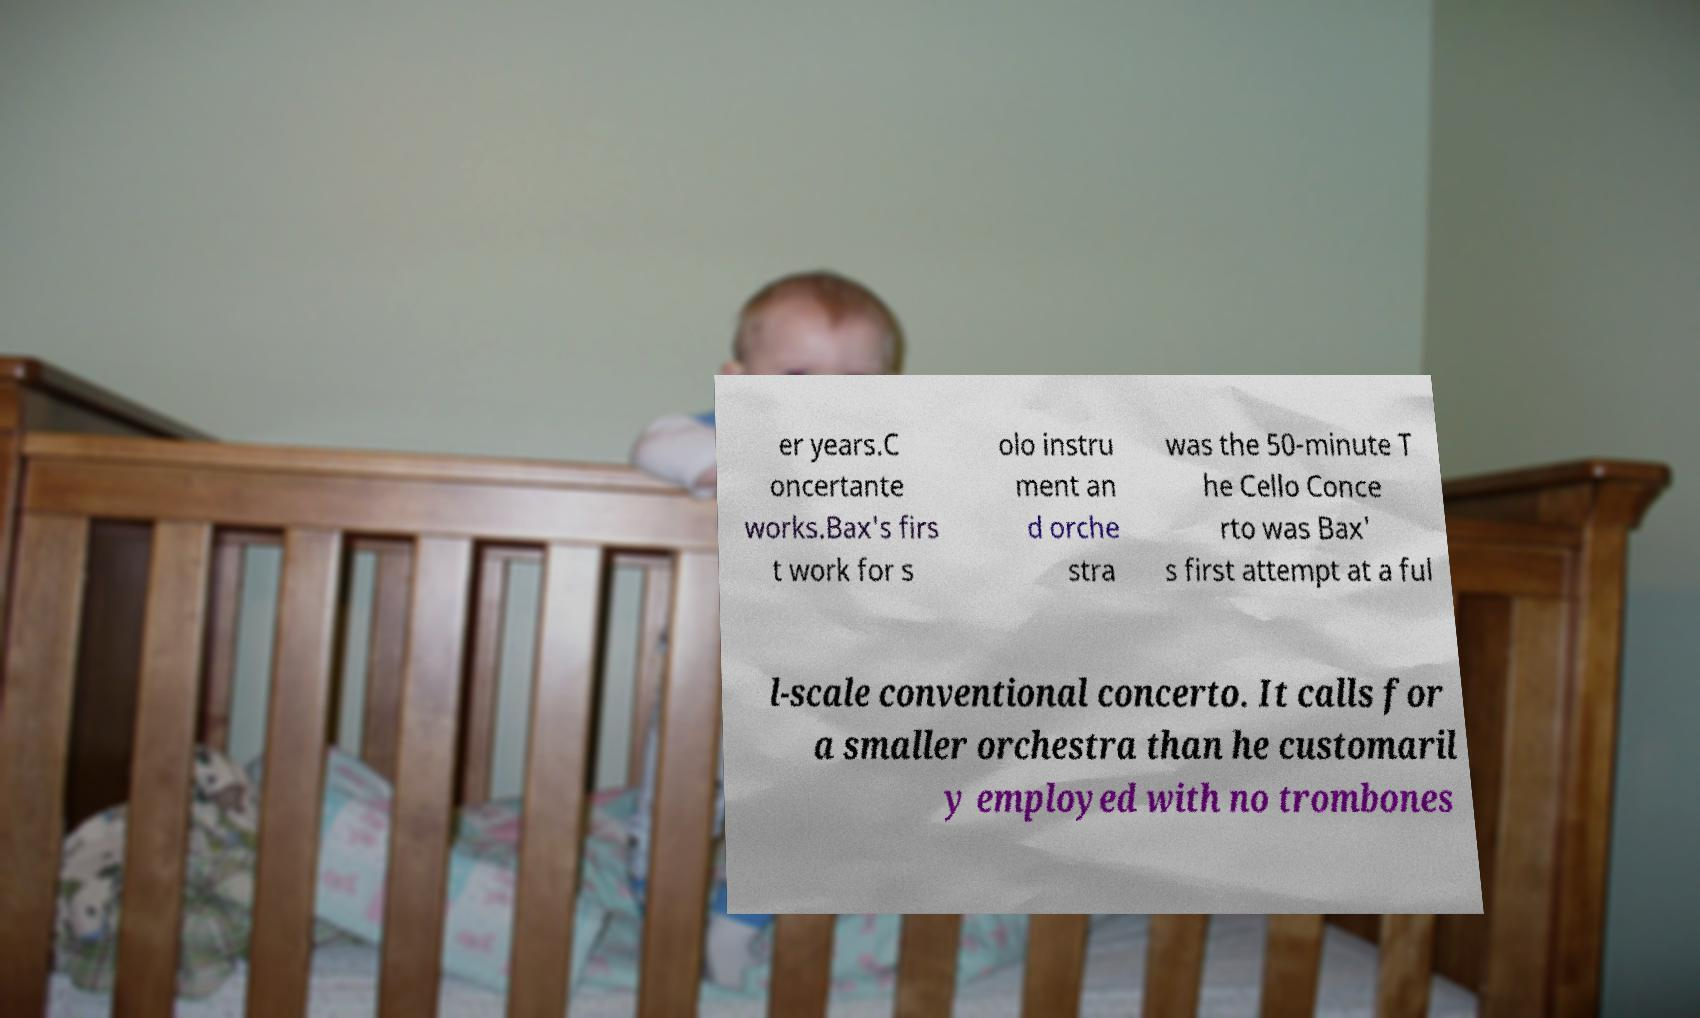There's text embedded in this image that I need extracted. Can you transcribe it verbatim? er years.C oncertante works.Bax's firs t work for s olo instru ment an d orche stra was the 50-minute T he Cello Conce rto was Bax' s first attempt at a ful l-scale conventional concerto. It calls for a smaller orchestra than he customaril y employed with no trombones 